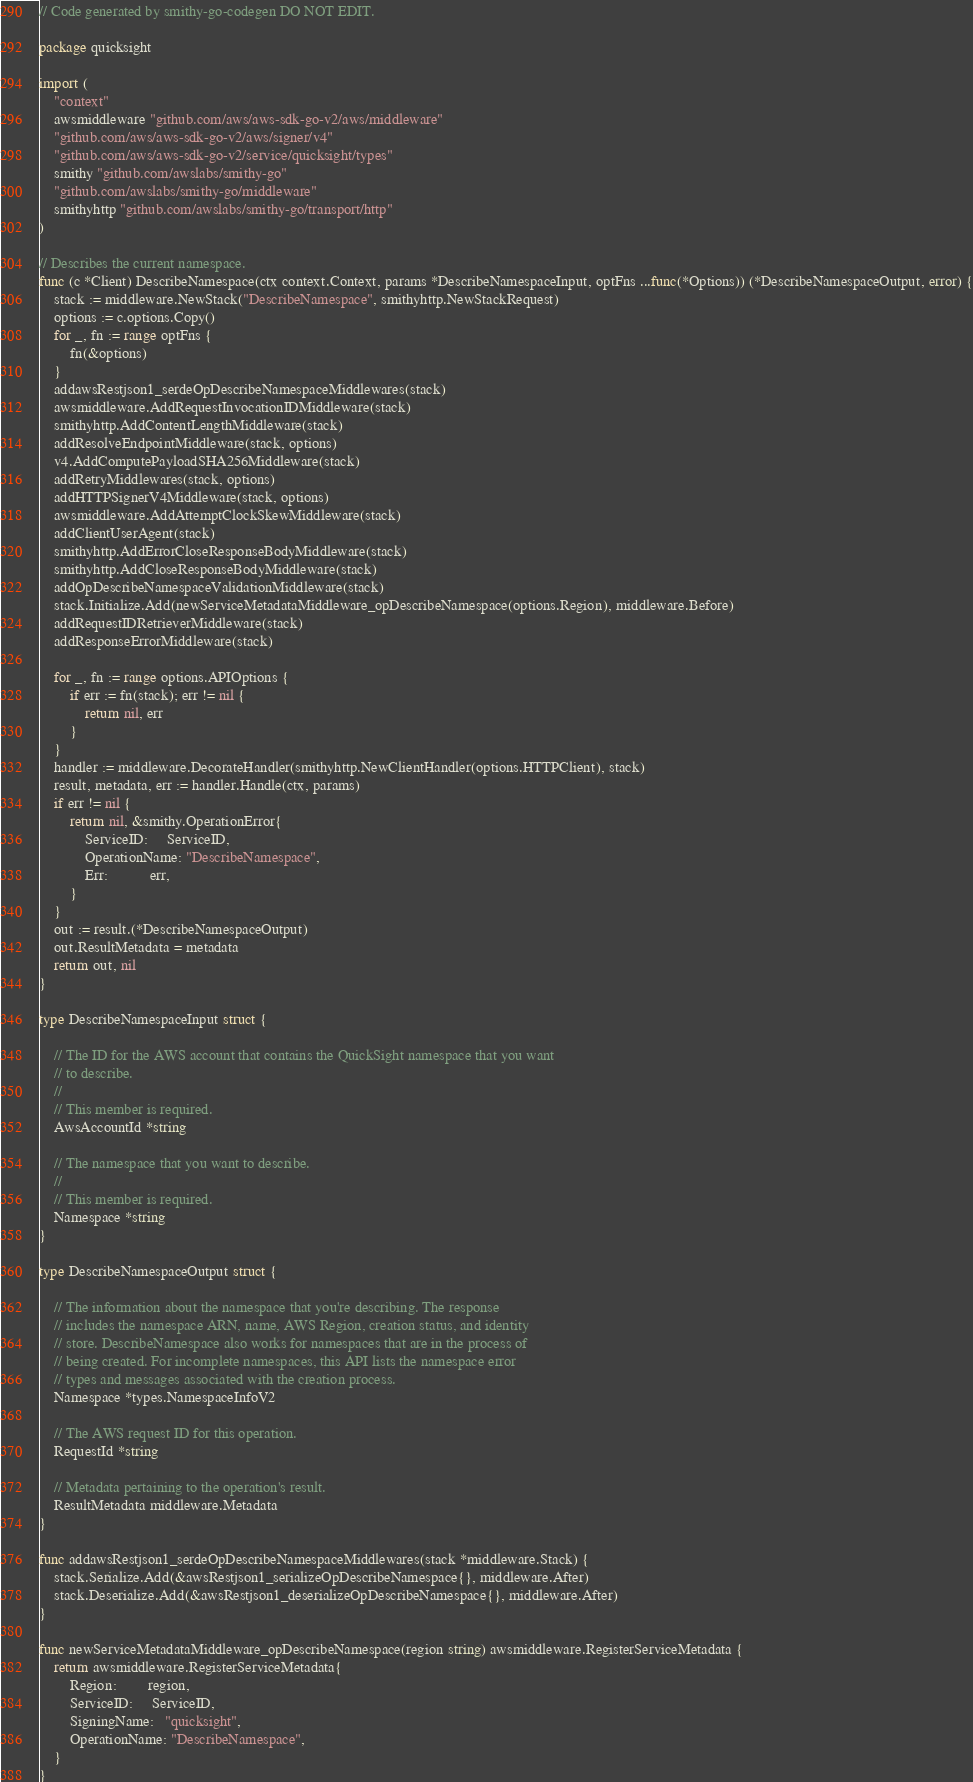Convert code to text. <code><loc_0><loc_0><loc_500><loc_500><_Go_>// Code generated by smithy-go-codegen DO NOT EDIT.

package quicksight

import (
	"context"
	awsmiddleware "github.com/aws/aws-sdk-go-v2/aws/middleware"
	"github.com/aws/aws-sdk-go-v2/aws/signer/v4"
	"github.com/aws/aws-sdk-go-v2/service/quicksight/types"
	smithy "github.com/awslabs/smithy-go"
	"github.com/awslabs/smithy-go/middleware"
	smithyhttp "github.com/awslabs/smithy-go/transport/http"
)

// Describes the current namespace.
func (c *Client) DescribeNamespace(ctx context.Context, params *DescribeNamespaceInput, optFns ...func(*Options)) (*DescribeNamespaceOutput, error) {
	stack := middleware.NewStack("DescribeNamespace", smithyhttp.NewStackRequest)
	options := c.options.Copy()
	for _, fn := range optFns {
		fn(&options)
	}
	addawsRestjson1_serdeOpDescribeNamespaceMiddlewares(stack)
	awsmiddleware.AddRequestInvocationIDMiddleware(stack)
	smithyhttp.AddContentLengthMiddleware(stack)
	addResolveEndpointMiddleware(stack, options)
	v4.AddComputePayloadSHA256Middleware(stack)
	addRetryMiddlewares(stack, options)
	addHTTPSignerV4Middleware(stack, options)
	awsmiddleware.AddAttemptClockSkewMiddleware(stack)
	addClientUserAgent(stack)
	smithyhttp.AddErrorCloseResponseBodyMiddleware(stack)
	smithyhttp.AddCloseResponseBodyMiddleware(stack)
	addOpDescribeNamespaceValidationMiddleware(stack)
	stack.Initialize.Add(newServiceMetadataMiddleware_opDescribeNamespace(options.Region), middleware.Before)
	addRequestIDRetrieverMiddleware(stack)
	addResponseErrorMiddleware(stack)

	for _, fn := range options.APIOptions {
		if err := fn(stack); err != nil {
			return nil, err
		}
	}
	handler := middleware.DecorateHandler(smithyhttp.NewClientHandler(options.HTTPClient), stack)
	result, metadata, err := handler.Handle(ctx, params)
	if err != nil {
		return nil, &smithy.OperationError{
			ServiceID:     ServiceID,
			OperationName: "DescribeNamespace",
			Err:           err,
		}
	}
	out := result.(*DescribeNamespaceOutput)
	out.ResultMetadata = metadata
	return out, nil
}

type DescribeNamespaceInput struct {

	// The ID for the AWS account that contains the QuickSight namespace that you want
	// to describe.
	//
	// This member is required.
	AwsAccountId *string

	// The namespace that you want to describe.
	//
	// This member is required.
	Namespace *string
}

type DescribeNamespaceOutput struct {

	// The information about the namespace that you're describing. The response
	// includes the namespace ARN, name, AWS Region, creation status, and identity
	// store. DescribeNamespace also works for namespaces that are in the process of
	// being created. For incomplete namespaces, this API lists the namespace error
	// types and messages associated with the creation process.
	Namespace *types.NamespaceInfoV2

	// The AWS request ID for this operation.
	RequestId *string

	// Metadata pertaining to the operation's result.
	ResultMetadata middleware.Metadata
}

func addawsRestjson1_serdeOpDescribeNamespaceMiddlewares(stack *middleware.Stack) {
	stack.Serialize.Add(&awsRestjson1_serializeOpDescribeNamespace{}, middleware.After)
	stack.Deserialize.Add(&awsRestjson1_deserializeOpDescribeNamespace{}, middleware.After)
}

func newServiceMetadataMiddleware_opDescribeNamespace(region string) awsmiddleware.RegisterServiceMetadata {
	return awsmiddleware.RegisterServiceMetadata{
		Region:        region,
		ServiceID:     ServiceID,
		SigningName:   "quicksight",
		OperationName: "DescribeNamespace",
	}
}
</code> 